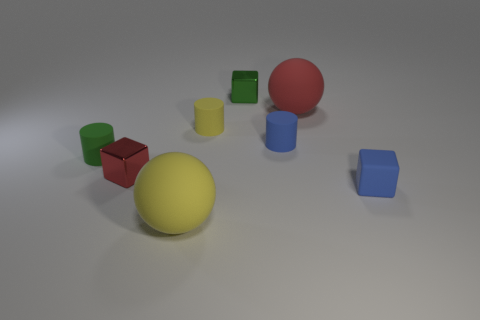Is there a tiny thing that has the same material as the yellow cylinder?
Offer a very short reply. Yes. There is another green block that is the same size as the rubber cube; what material is it?
Your answer should be compact. Metal. The yellow thing that is behind the blue rubber thing right of the large red matte ball is made of what material?
Keep it short and to the point. Rubber. There is a green object that is to the left of the tiny green shiny cube; is it the same shape as the tiny yellow rubber thing?
Your answer should be very brief. Yes. There is another tiny block that is made of the same material as the green cube; what color is it?
Keep it short and to the point. Red. There is a tiny thing to the left of the small red metal thing; what is it made of?
Ensure brevity in your answer.  Rubber. Is the shape of the large red rubber object the same as the small green thing on the right side of the tiny yellow rubber cylinder?
Your answer should be compact. No. The cube that is in front of the red rubber object and to the left of the blue cylinder is made of what material?
Provide a short and direct response. Metal. There is a matte cube that is the same size as the blue matte cylinder; what color is it?
Offer a very short reply. Blue. Is the material of the small blue cylinder the same as the sphere in front of the large red sphere?
Provide a short and direct response. Yes. 